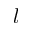Convert formula to latex. <formula><loc_0><loc_0><loc_500><loc_500>l</formula> 